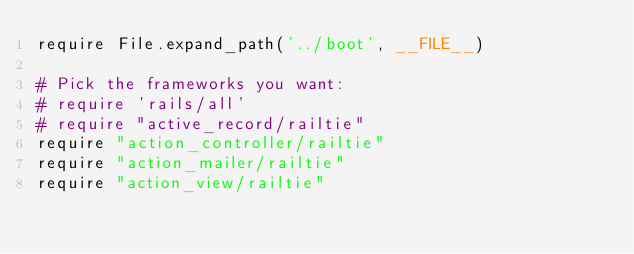<code> <loc_0><loc_0><loc_500><loc_500><_Ruby_>require File.expand_path('../boot', __FILE__)

# Pick the frameworks you want:
# require 'rails/all'
# require "active_record/railtie"
require "action_controller/railtie"
require "action_mailer/railtie"
require "action_view/railtie"</code> 